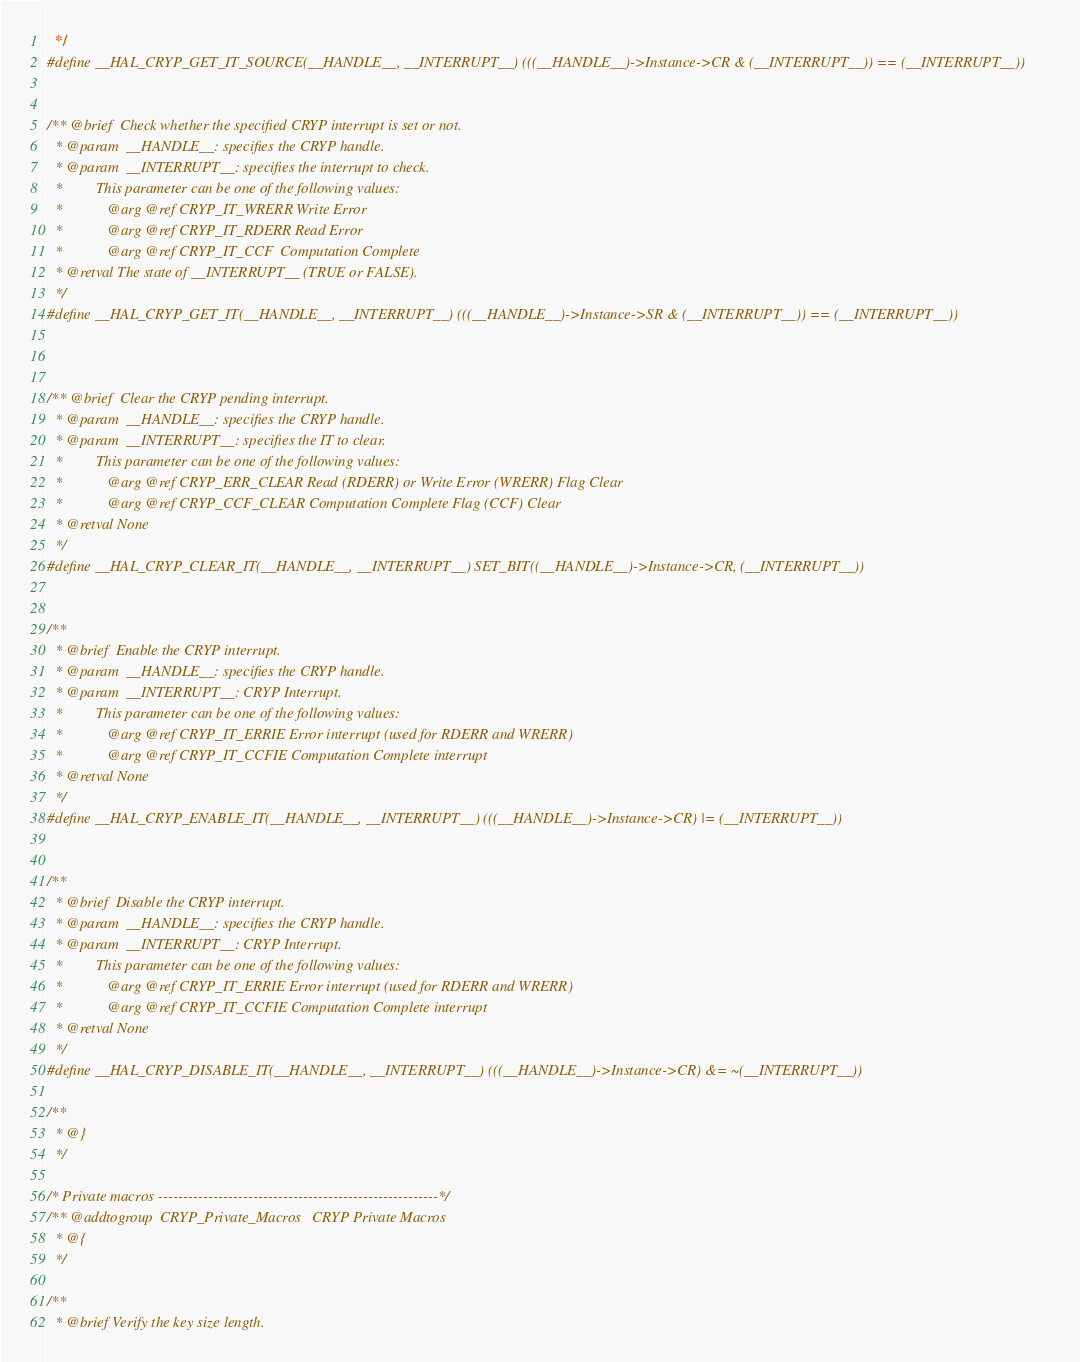Convert code to text. <code><loc_0><loc_0><loc_500><loc_500><_C_>  */
#define __HAL_CRYP_GET_IT_SOURCE(__HANDLE__, __INTERRUPT__) (((__HANDLE__)->Instance->CR & (__INTERRUPT__)) == (__INTERRUPT__))


/** @brief  Check whether the specified CRYP interrupt is set or not.
  * @param  __HANDLE__: specifies the CRYP handle.
  * @param  __INTERRUPT__: specifies the interrupt to check.
  *         This parameter can be one of the following values:
  *            @arg @ref CRYP_IT_WRERR Write Error 
  *            @arg @ref CRYP_IT_RDERR Read Error 
  *            @arg @ref CRYP_IT_CCF  Computation Complete                 
  * @retval The state of __INTERRUPT__ (TRUE or FALSE).
  */
#define __HAL_CRYP_GET_IT(__HANDLE__, __INTERRUPT__) (((__HANDLE__)->Instance->SR & (__INTERRUPT__)) == (__INTERRUPT__))



/** @brief  Clear the CRYP pending interrupt.
  * @param  __HANDLE__: specifies the CRYP handle.
  * @param  __INTERRUPT__: specifies the IT to clear.
  *         This parameter can be one of the following values:
  *            @arg @ref CRYP_ERR_CLEAR Read (RDERR) or Write Error (WRERR) Flag Clear
  *            @arg @ref CRYP_CCF_CLEAR Computation Complete Flag (CCF) Clear    
  * @retval None
  */
#define __HAL_CRYP_CLEAR_IT(__HANDLE__, __INTERRUPT__) SET_BIT((__HANDLE__)->Instance->CR, (__INTERRUPT__))


/**
  * @brief  Enable the CRYP interrupt. 
  * @param  __HANDLE__: specifies the CRYP handle.   
  * @param  __INTERRUPT__: CRYP Interrupt.
  *         This parameter can be one of the following values:  
  *            @arg @ref CRYP_IT_ERRIE Error interrupt (used for RDERR and WRERR)
  *            @arg @ref CRYP_IT_CCFIE Computation Complete interrupt    
  * @retval None
  */
#define __HAL_CRYP_ENABLE_IT(__HANDLE__, __INTERRUPT__) (((__HANDLE__)->Instance->CR) |= (__INTERRUPT__))


/**
  * @brief  Disable the CRYP interrupt.
  * @param  __HANDLE__: specifies the CRYP handle.  
  * @param  __INTERRUPT__: CRYP Interrupt.
  *         This parameter can be one of the following values:  
  *            @arg @ref CRYP_IT_ERRIE Error interrupt (used for RDERR and WRERR)
  *            @arg @ref CRYP_IT_CCFIE Computation Complete interrupt    
  * @retval None
  */
#define __HAL_CRYP_DISABLE_IT(__HANDLE__, __INTERRUPT__) (((__HANDLE__)->Instance->CR) &= ~(__INTERRUPT__))

/**
  * @}
  */

/* Private macros --------------------------------------------------------*/
/** @addtogroup  CRYP_Private_Macros   CRYP Private Macros
  * @{
  */

/**
  * @brief Verify the key size length.</code> 